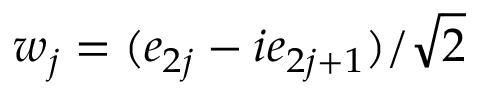Convert formula to latex. <formula><loc_0><loc_0><loc_500><loc_500>w _ { j } = ( e _ { 2 j } - i e _ { 2 j + 1 } ) / { \sqrt { 2 } }</formula> 